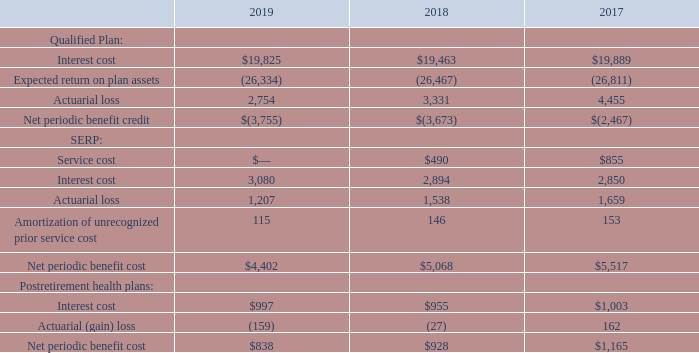Net periodic benefit cost — The components of the fiscal year net periodic benefit cost were as follows (in thousands):
Changes in presentation —As discussed in Note 1, Nature of Operations and Summary of Significant Accounting Policies, we adopted ASU 2017-07 during the first quarter of 2019 using the retrospective method, which changed the financial statement presentation of service costs and the other components of net periodic benefit cost. The service cost component continues to be included in operating income; however, the other components are now presented in a separate line below earnings from operations captioned “Other pension and post-retirement expenses, net” in our consolidated statements of earnings. Further, in connection with the adoption, plan administrative expenses historically presented as a component of service cost are now presented as a component of expected return on plan assets. The prior year components of net periodic benefit costs and assumptions on the long-term rate of return on assets have been recast to conform to current year presentation.
Prior service costs are amortized on a straight-line basis from date of participation to full eligibility. Unrecognized gains or losses are amortized using the “corridor approach” under which the net gain or loss in excess of 10% of the greater of the PBO or the market-related value of the assets, if applicable, is amortized. For our Qualified Plan, actuarial losses are amortized over the average future expected lifetime of all participants expected to receive benefits. For our SERP, actuarial losses are amortized over the expected remaining future lifetime for inactive participants, and for our postretirement health plans, actuarial losses are amortized over the expected remaining future lifetime of inactive participants expected to receive benefits.
How are prior service costs amortized? On a straight-line basis from date of participation to full eligibility. For SERP, how are actuarial losses amortized? Over the expected remaining future lifetime for inactive participants. For SERP, what is the net periodic benefit cost for 2019?
Answer scale should be: thousand. $4,402. For Qualified Plan, what is the difference in interest cost between 2018 and 2019?
Answer scale should be: thousand. $19,825-$19,463
Answer: 362. For SERP, what is the average actuarial loss for the years 2017-2019?
Answer scale should be: thousand. (1,207+1,538+1,659)/3
Answer: 1468. For Postretirement health plans, what is the percentage constitution of interest cost among the net periodic benefit cost in 2017?
Answer scale should be: percent. 1,003/1,165
Answer: 86.09. 